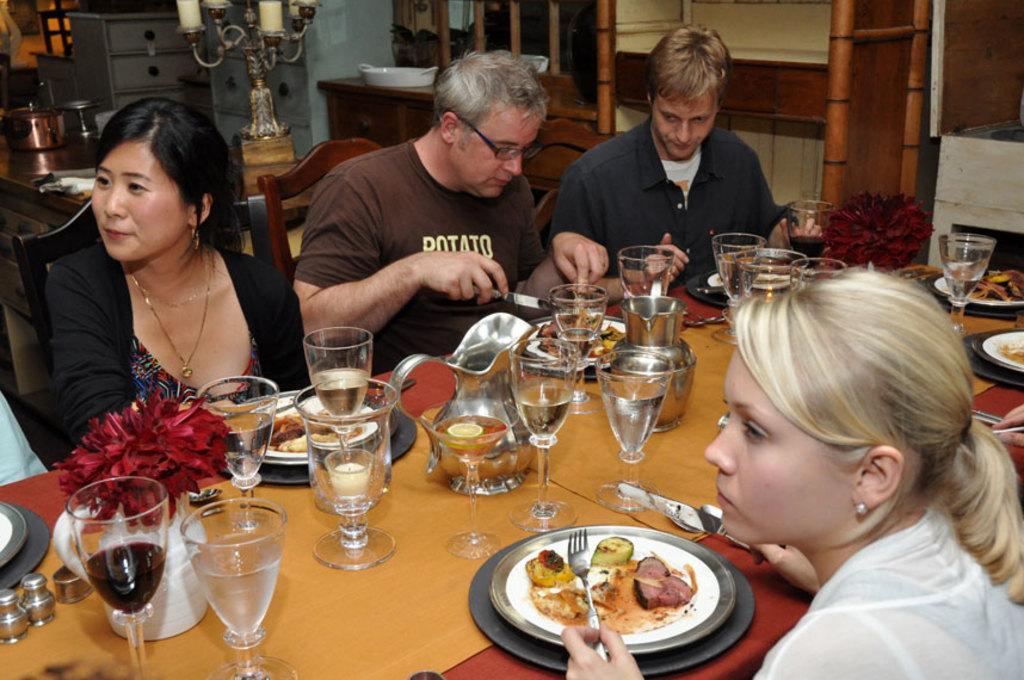Please provide a concise description of this image. In this image we can see few persons sitting on chairs taking food at a dining table. On that table we can see food on plates, few glasses, knife, fork, flower vase. behind the people there is a cooking vessel, candle stand, table and a tray. we can see house plant. 